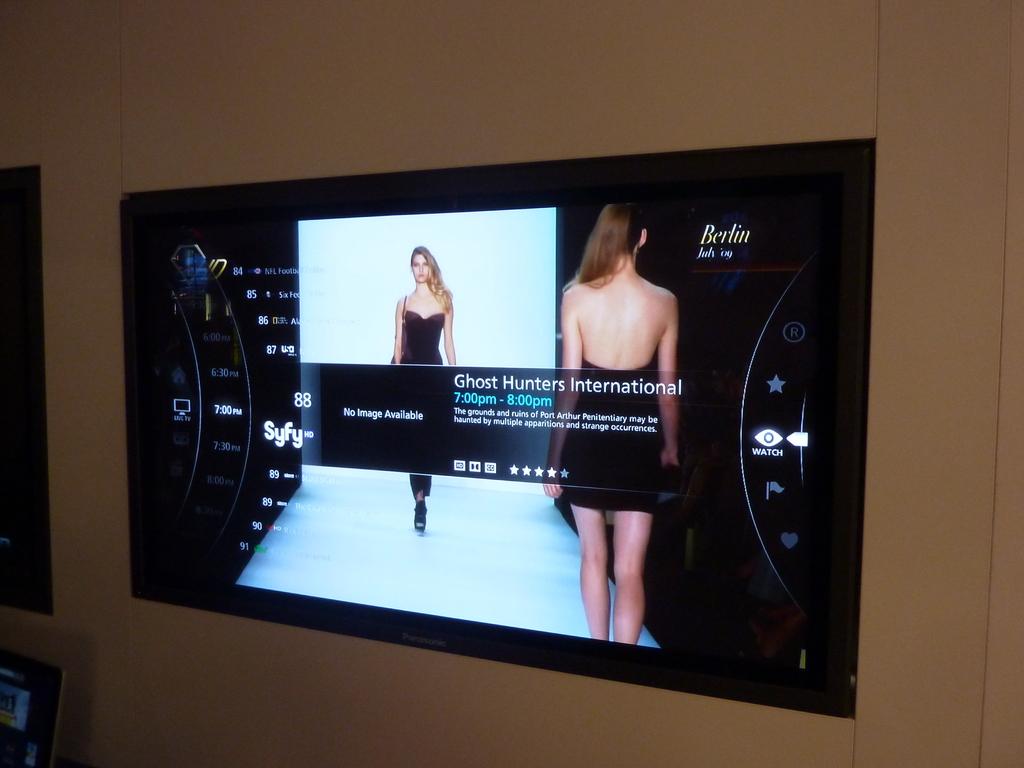What is the title of the tv show?
Keep it short and to the point. Ghost hunters international. 